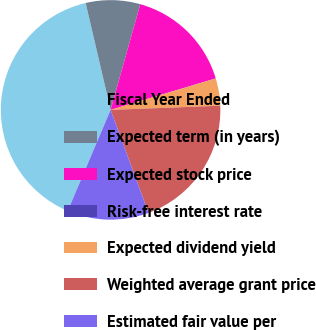Convert chart. <chart><loc_0><loc_0><loc_500><loc_500><pie_chart><fcel>Fiscal Year Ended<fcel>Expected term (in years)<fcel>Expected stock price<fcel>Risk-free interest rate<fcel>Expected dividend yield<fcel>Weighted average grant price<fcel>Estimated fair value per<nl><fcel>39.96%<fcel>8.01%<fcel>16.0%<fcel>0.02%<fcel>4.01%<fcel>19.99%<fcel>12.0%<nl></chart> 